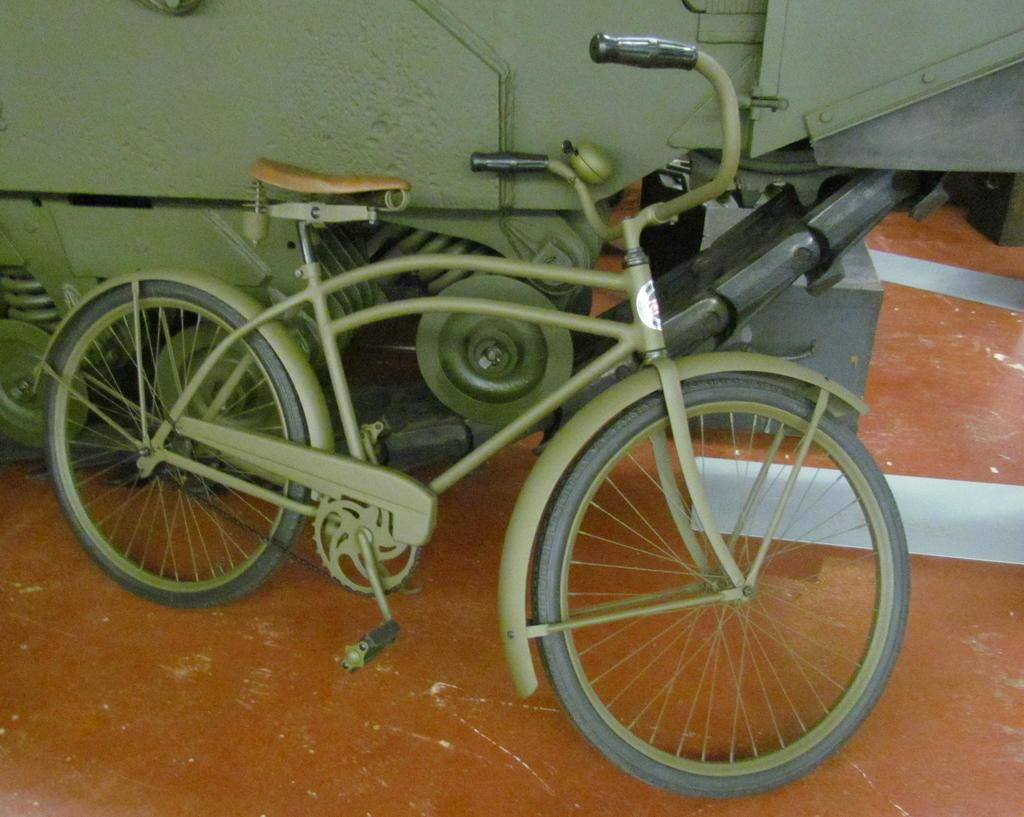What type of bicycle is in the image? There is a green bicycle in the image. What is located behind the bicycle? There is a vehicle behind the bicycle. What color is the surface in the image? The surface in the image is brown. What type of cream can be seen on the bicycle in the image? There is no cream visible on the bicycle in the image. 